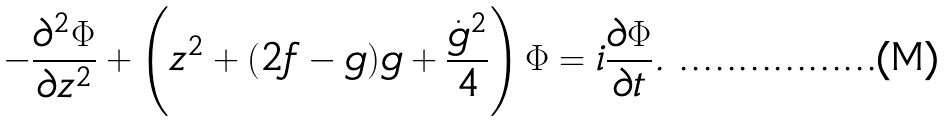Convert formula to latex. <formula><loc_0><loc_0><loc_500><loc_500>- \frac { \partial ^ { 2 } \Phi } { \partial z ^ { 2 } } + \left ( z ^ { 2 } + ( 2 f - g ) g + \frac { \dot { g } ^ { 2 } } { 4 } \right ) \Phi = i \frac { \partial \Phi } { \partial t } .</formula> 